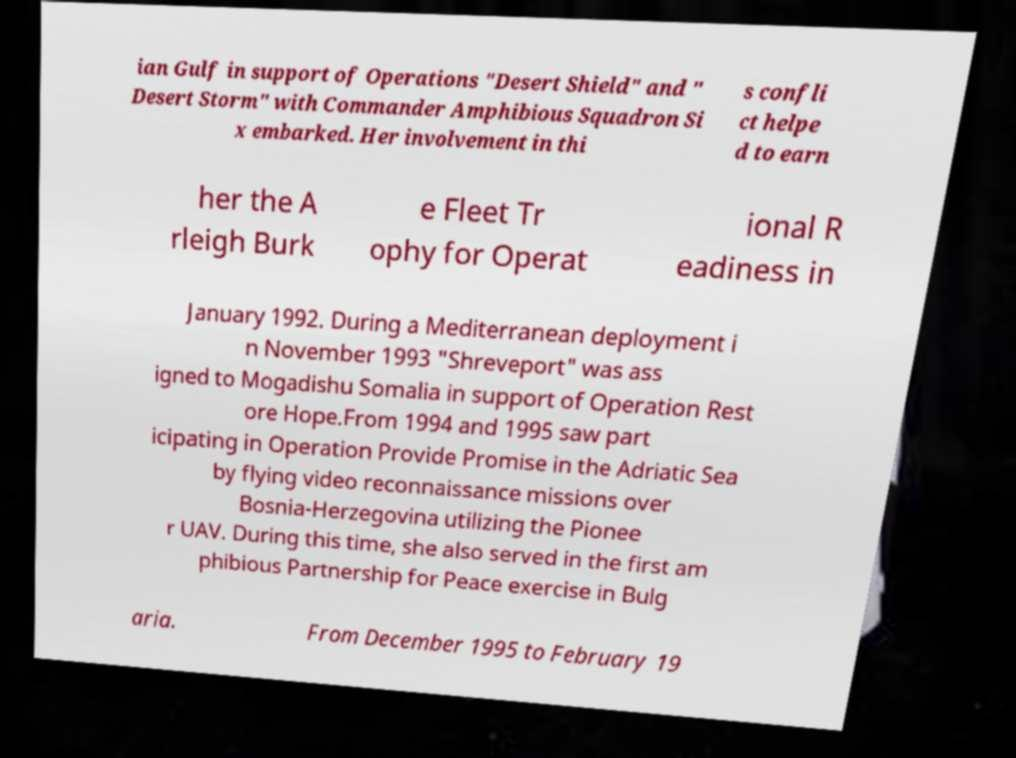Could you extract and type out the text from this image? ian Gulf in support of Operations "Desert Shield" and " Desert Storm" with Commander Amphibious Squadron Si x embarked. Her involvement in thi s confli ct helpe d to earn her the A rleigh Burk e Fleet Tr ophy for Operat ional R eadiness in January 1992. During a Mediterranean deployment i n November 1993 "Shreveport" was ass igned to Mogadishu Somalia in support of Operation Rest ore Hope.From 1994 and 1995 saw part icipating in Operation Provide Promise in the Adriatic Sea by flying video reconnaissance missions over Bosnia-Herzegovina utilizing the Pionee r UAV. During this time, she also served in the first am phibious Partnership for Peace exercise in Bulg aria. From December 1995 to February 19 